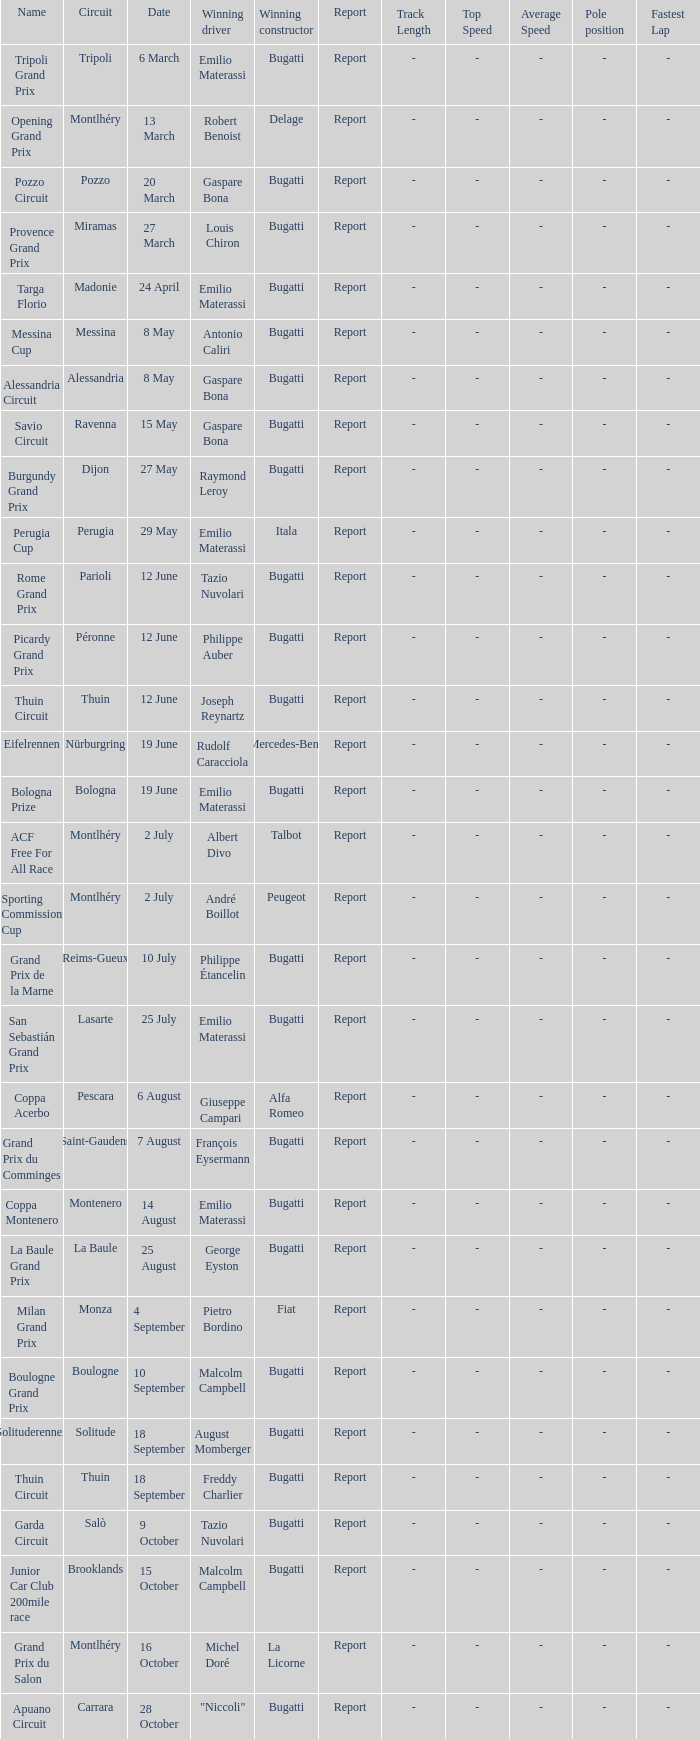When did Gaspare Bona win the Pozzo Circuit? 20 March. 